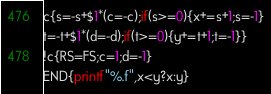<code> <loc_0><loc_0><loc_500><loc_500><_Awk_>c{s=-s+$1*(c=-c);if(s>=0){x+=s+1;s=-1}
t=-t+$1*(d=-d);if(t>=0){y+=t+1;t=-1}}
!c{RS=FS;c=1;d=-1}
END{printf"%.f",x<y?x:y}</code> 